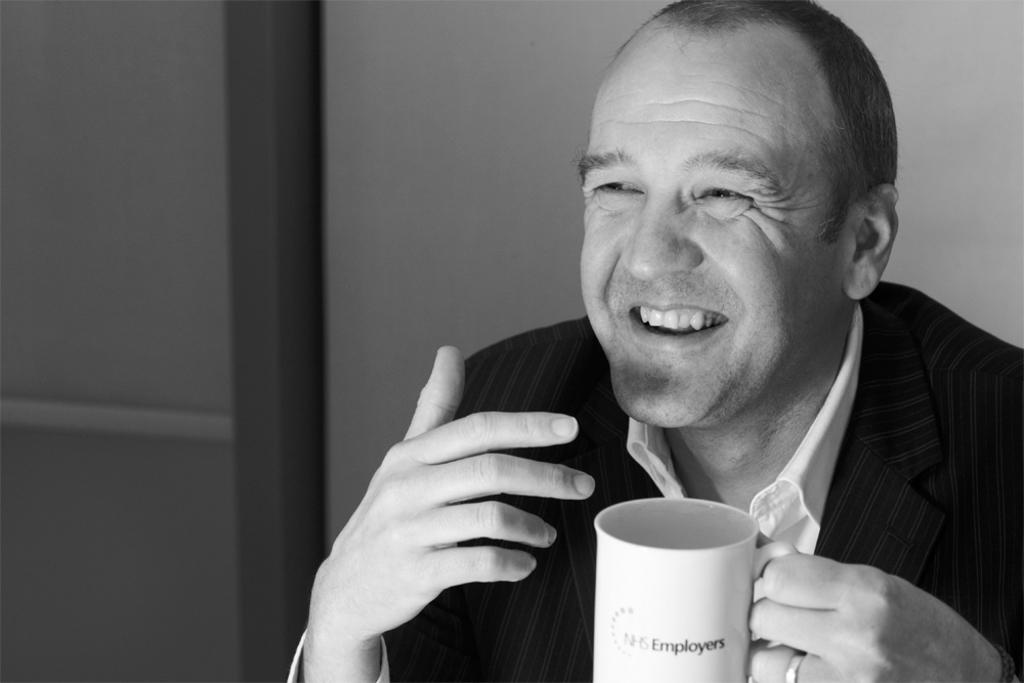What is the main subject of the image? There is a man in the image. What is the man holding in the image? The man is holding a cup in one hand. What is the man's facial expression in the image? The man is smiling. What can be seen in the background of the image? There is a wall in the background of the image. Is the man using a fork to eat during the rainstorm in the image? There is no fork or rainstorm present in the image. 